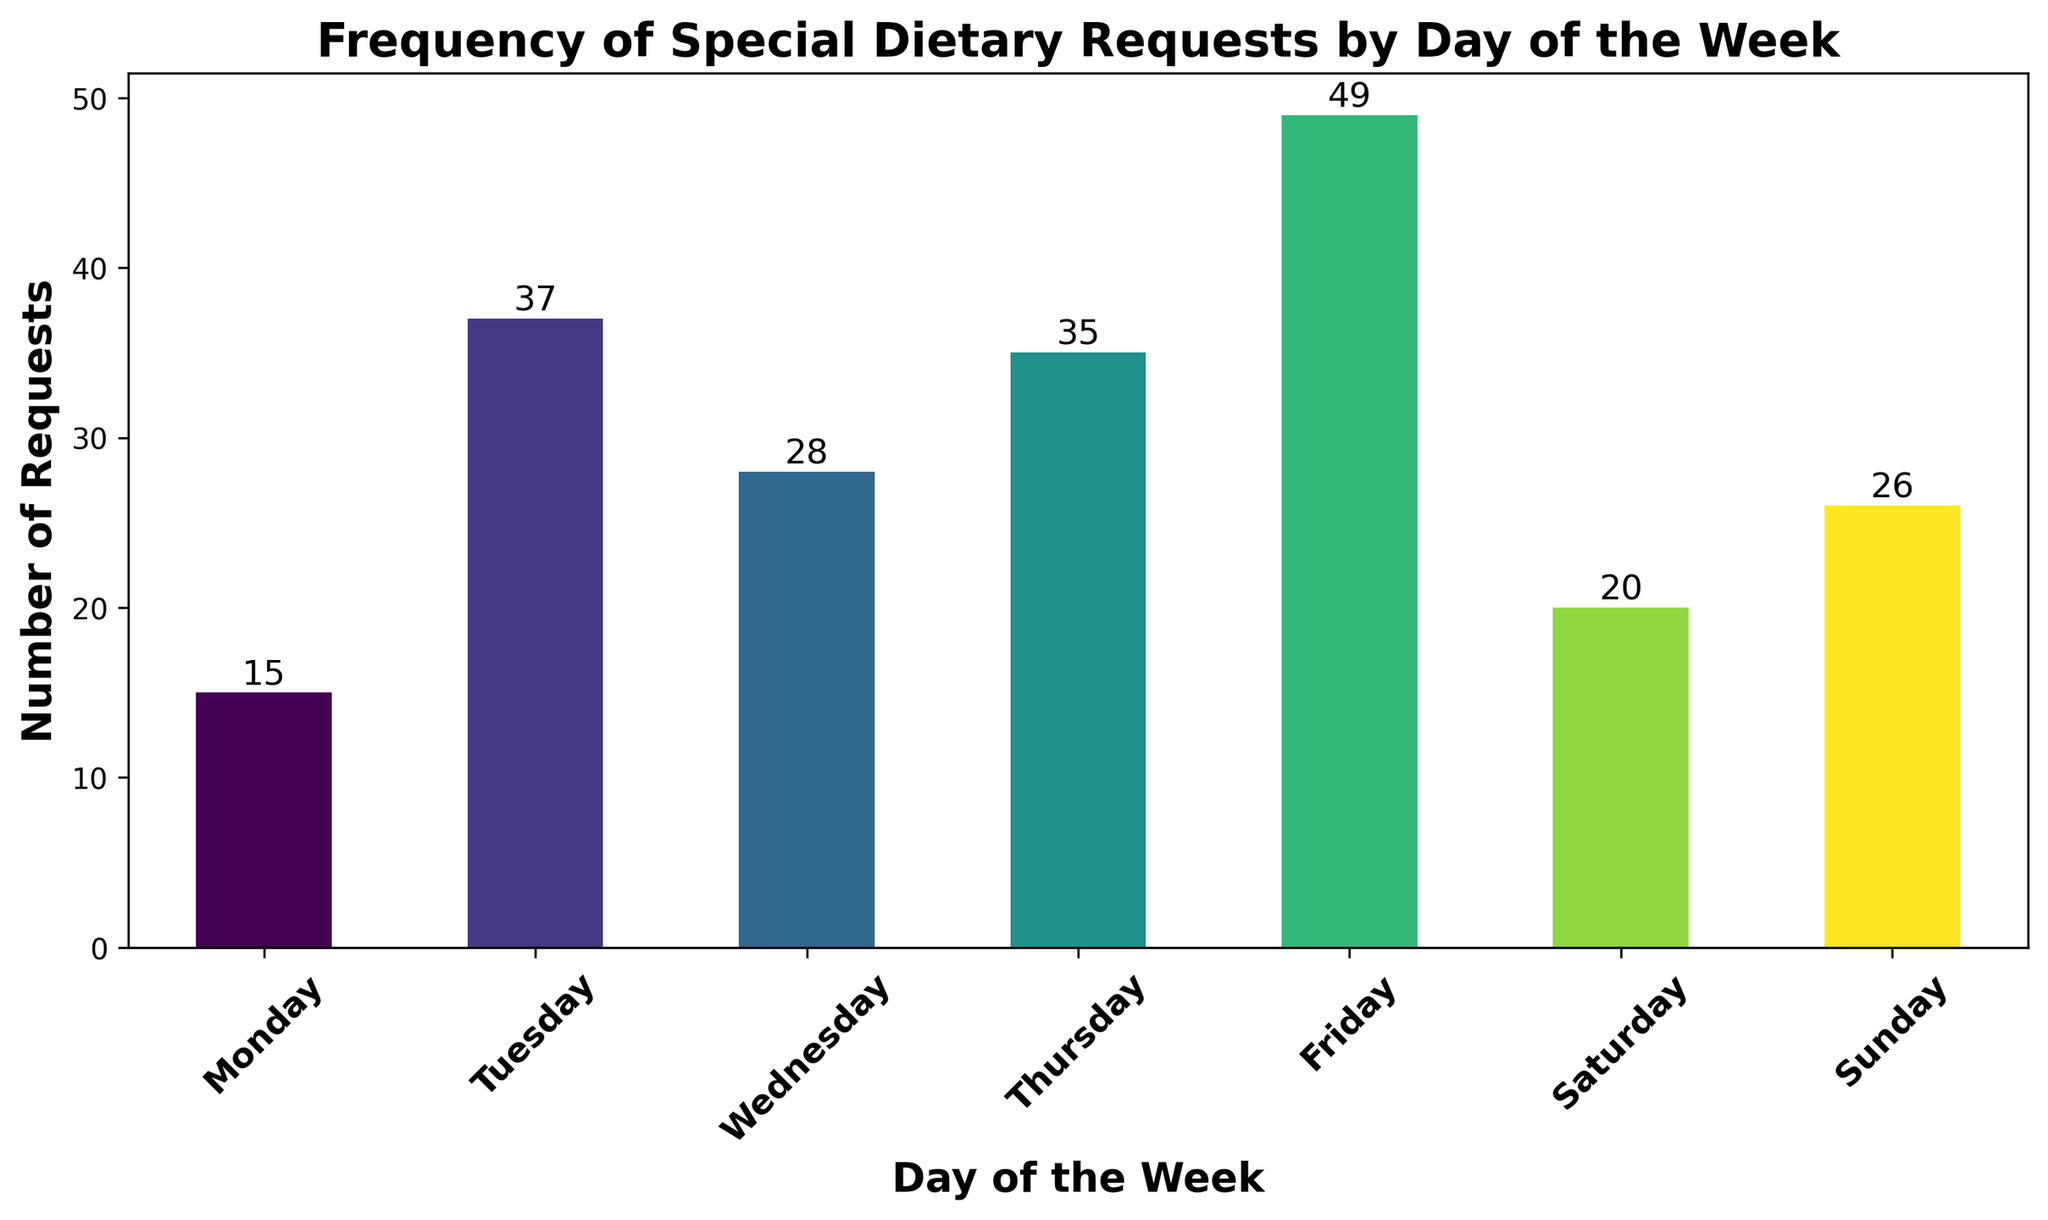Which day has the highest number of special dietary requests? To find this, look for the tallest bar in the histogram. The tallest bar represents Friday.
Answer: Friday Which day has the least number of special dietary requests? To find this, look for the shortest bar in the histogram. The shortest bar represents Monday.
Answer: Monday What is the total number of special dietary requests for the weekends (Saturday and Sunday)? Add the values corresponding to the bars for Saturday and Sunday: 8 (Saturday) + 7 (Saturday) + 10 (Sunday) + 9 (Sunday) + 7 (Saturday) + 7 (Sunday) = 33
Answer: 33 How many more special dietary requests were there on Friday compared to Monday? Subtract the number of requests on Monday from the number of requests on Friday: 49 (Friday) - 15 (Monday) = 34
Answer: 34 Which weekday has the second highest number of special dietary requests? Exclude the weekends and look for the second tallest bar among weekdays. The second tallest bar among weekdays is Thursday.
Answer: Thursday What is the total number of special dietary requests for weekdays (Monday to Friday)? Sum the values corresponding to the bars from Monday to Friday: 15 (Monday) + 37 (Tuesday) + 28 (Wednesday) + 35 (Thursday) + 49 (Friday) = 164
Answer: 164 Is the number of special dietary requests on Wednesday greater than the number of requests on Monday? Compare the heights of the bars for Wednesday and Monday. The bar for Wednesday is higher than the bar for Monday.
Answer: Yes What is the average number of special dietary requests per day for the entire week? Sum the number of requests for each day and then divide by the number of days to find the average: (15 + 37 + 28 + 35 + 49 + 20 + 26) / 7 = 210 / 7 = 30
Answer: 30 How many total special dietary requests were there on Thursday and Sunday combined? Add the values for Thursday and Sunday: 35 (Thursday) + 26 (Sunday) = 61
Answer: 61 